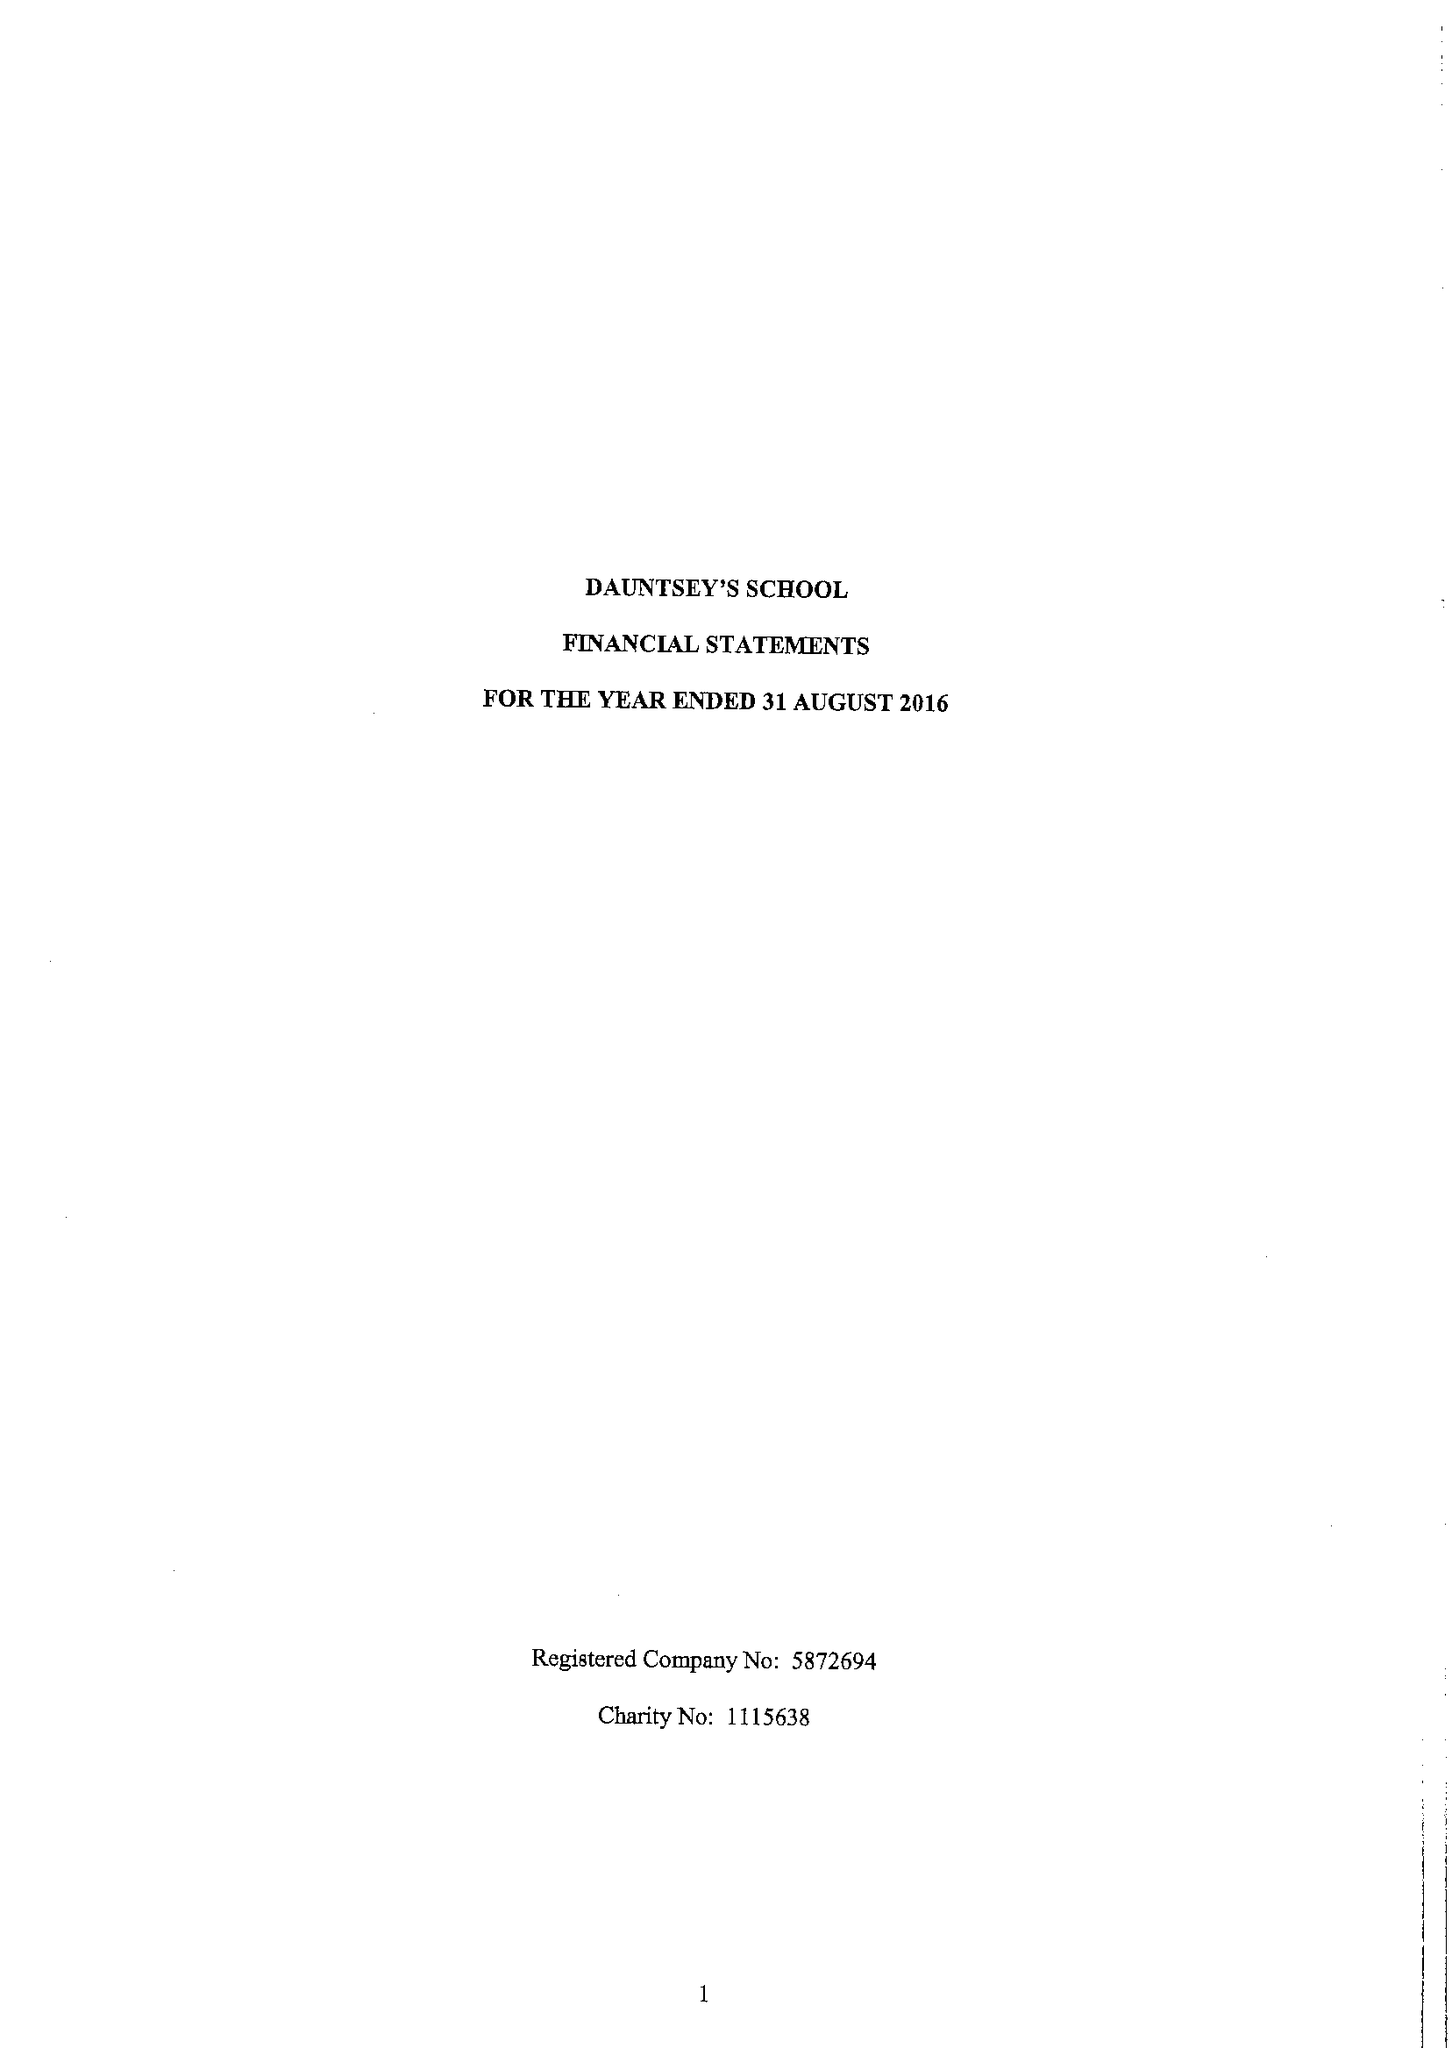What is the value for the income_annually_in_british_pounds?
Answer the question using a single word or phrase. 18039009.00 